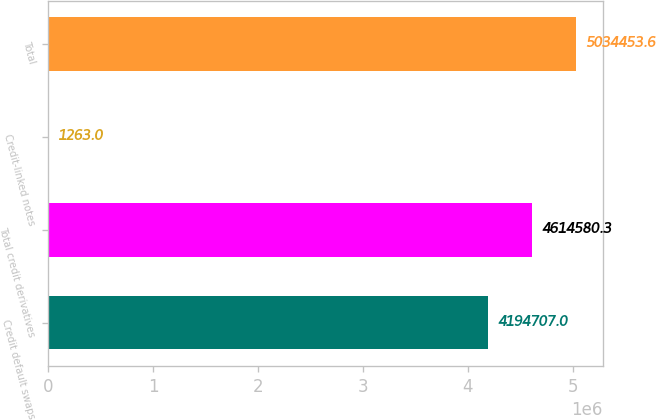<chart> <loc_0><loc_0><loc_500><loc_500><bar_chart><fcel>Credit default swaps<fcel>Total credit derivatives<fcel>Credit-linked notes<fcel>Total<nl><fcel>4.19471e+06<fcel>4.61458e+06<fcel>1263<fcel>5.03445e+06<nl></chart> 